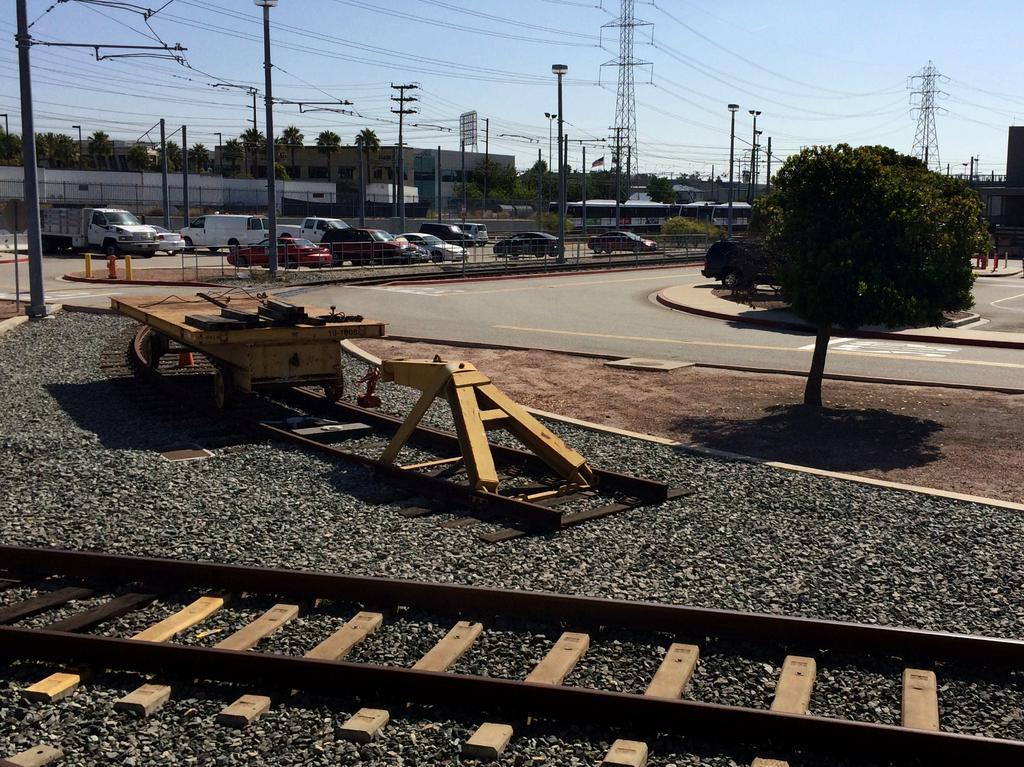Could you give a brief overview of what you see in this image? In this image I see the track over here and I see the stones and I see the path. In the background I see number of cars, trees, poles, wires, towers and the buildings and I see the sky which is clear. 